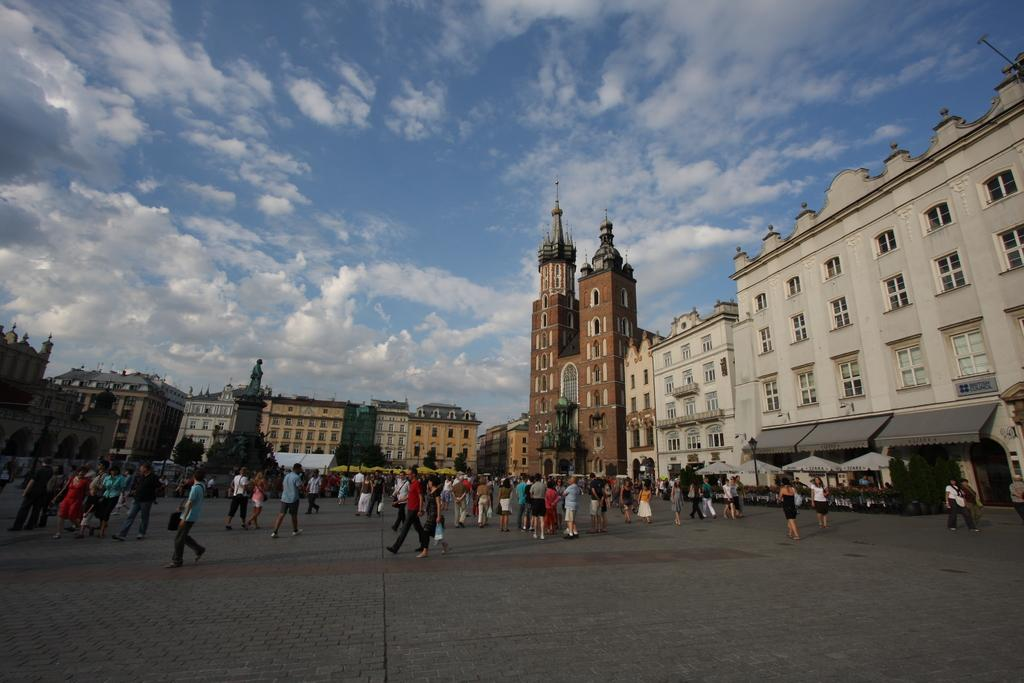What can be seen in the image that people might walk on? There is a path in the image that many people are walking on. What is visible in the background of the image? There are buildings with windows in the background, and the sky is visible. What can be observed in the sky? Clouds are present in the sky. How many sisters are holding a bottle on the path in the image? There is no mention of a bottle or sisters in the image; it features a path with many people walking on it and buildings with windows in the background. 